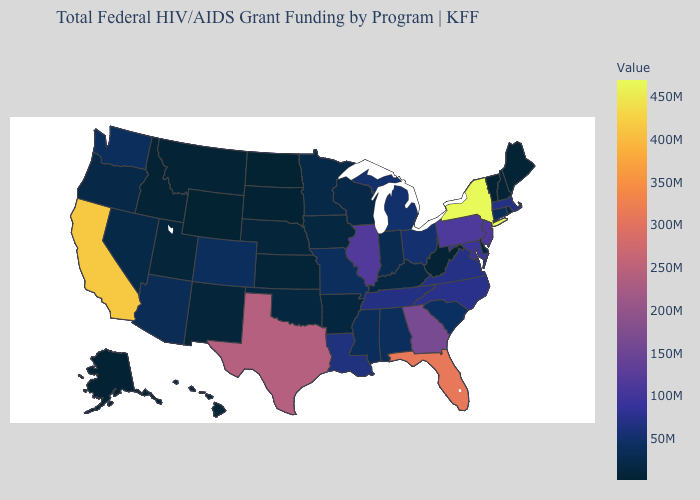Among the states that border California , which have the highest value?
Write a very short answer. Arizona. Which states have the highest value in the USA?
Give a very brief answer. New York. Which states have the highest value in the USA?
Write a very short answer. New York. Does Ohio have the lowest value in the MidWest?
Be succinct. No. Is the legend a continuous bar?
Concise answer only. Yes. Which states have the highest value in the USA?
Short answer required. New York. 